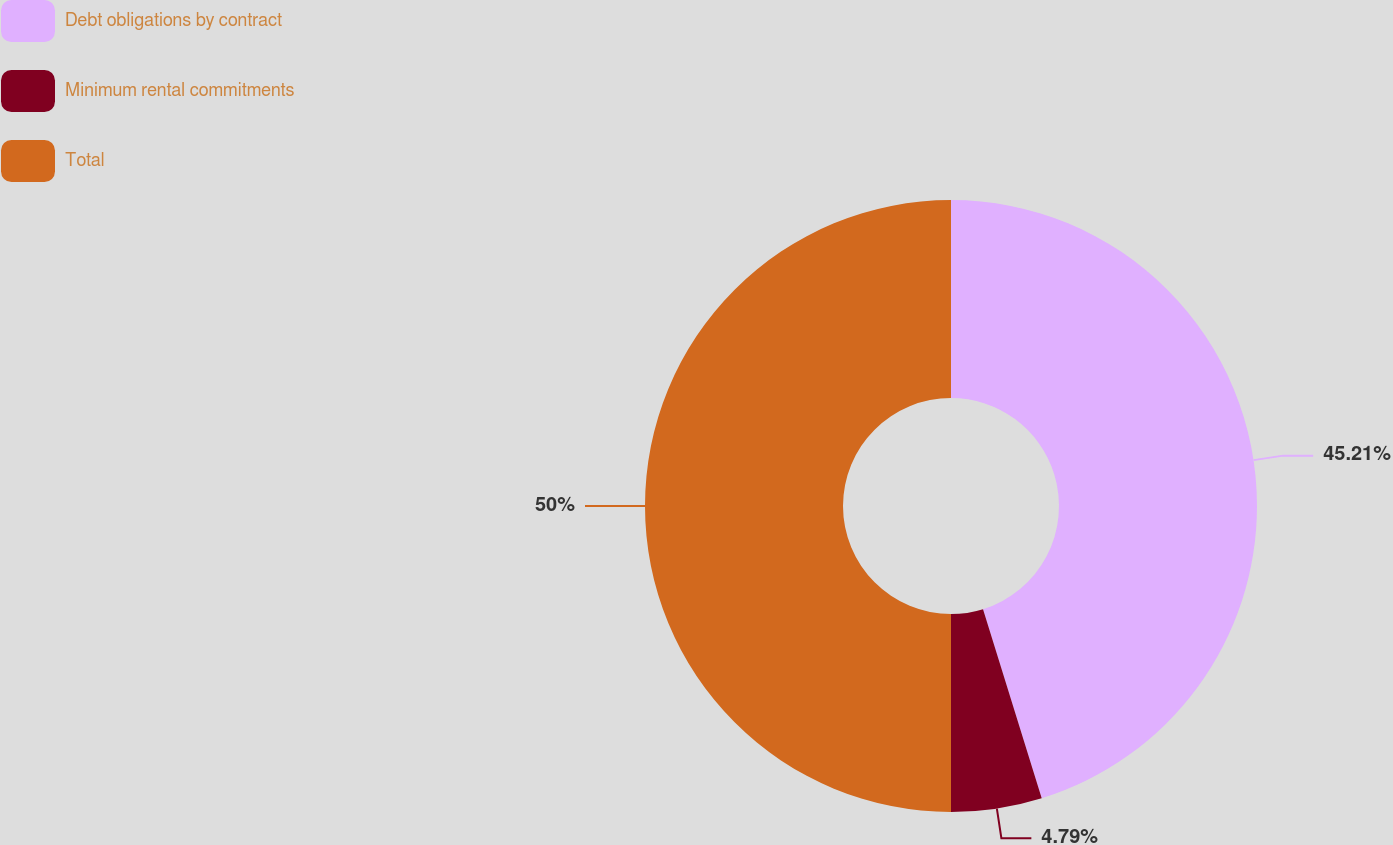Convert chart. <chart><loc_0><loc_0><loc_500><loc_500><pie_chart><fcel>Debt obligations by contract<fcel>Minimum rental commitments<fcel>Total<nl><fcel>45.21%<fcel>4.79%<fcel>50.0%<nl></chart> 